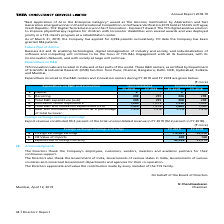According to Tata Consultancy Services's financial document, What information does the table show? Foreign exchange earnings and outgo. The document states: "Foreign exchange earnings and outgo..." Also, What portion of total unconsolidated revenue in FY 2019 constitutes of export revenue? According to the financial document, 93.3 (percentage). The relevant text states: "Export revenue constituted 93.3 percent of the total unconsolidated revenue in FY 2019 (92.2 percent in FY 2018)...." Also, What portion of total unconsolidated revenue in FY 2018 constitutes of export revenue? According to the financial document, 92.2 (percentage). The relevant text states: "t of the total unconsolidated revenue in FY 2019 (92.2 percent in FY 2018)...." Also, can you calculate: What is the change in foreign exchange earnings between FY 2018 and FY 2019? Based on the calculation: 119,499-92,258 , the result is 27241. This is based on the information: "a. Foreign exchange earnings 119,499 92,258 b. CIF Value of imports 447 768 c. Expenditure in foreign currency 49,336 33,014 a. Foreign exchange earnings 119,499 92,258 b. CIF Value of imports 447 768..." The key data points involved are: 119,499, 92,258. Also, can you calculate: What is the change in Cost, Insurance and Freight (CIF) value of imports from FY 2018 to FY 2019? Based on the calculation: 447-768, the result is -321. This is based on the information: "rnings 119,499 92,258 b. CIF Value of imports 447 768 c. Expenditure in foreign currency 49,336 33,014 e earnings 119,499 92,258 b. CIF Value of imports 447 768 c. Expenditure in foreign currency 49,3..." The key data points involved are: 447, 768. Also, can you calculate: What is the ratio of foreign exchange earnings to expenditure in foreign currency in FY 2019? Based on the calculation: 119,499/49,336 , the result is 2.42. This is based on the information: "mports 447 768 c. Expenditure in foreign currency 49,336 33,014 a. Foreign exchange earnings 119,499 92,258 b. CIF Value of imports 447 768 c. Expenditure in foreign currency 49,336 33,014..." The key data points involved are: 119,499, 49,336. 